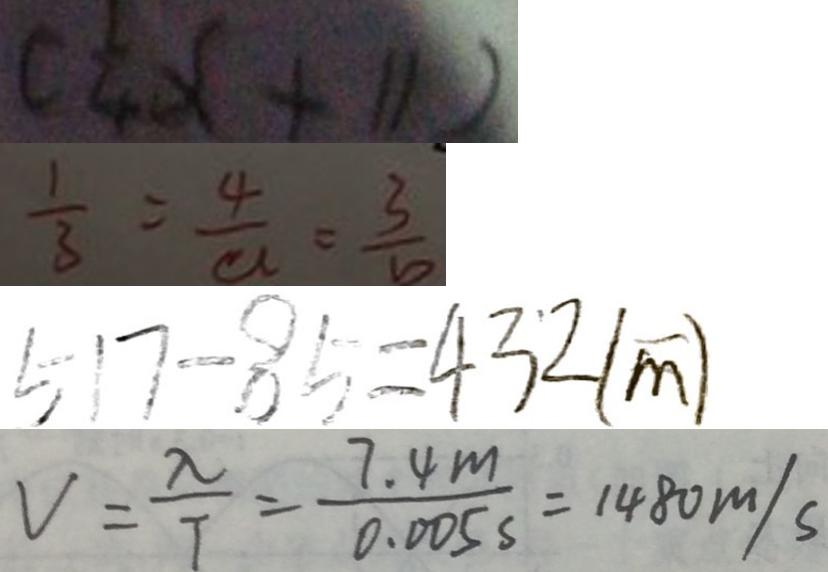Convert formula to latex. <formula><loc_0><loc_0><loc_500><loc_500>( \frac { 1 } { 4 } x + 1 1 ) 
 \frac { 1 } { 3 } = \frac { 4 } { a } = \frac { 3 } { b } 
 5 1 7 - 8 5 = 4 3 2 ( m ) 
 V = \frac { \lambda } { T } = \frac { 7 . 4 m } { 0 . 0 0 5 s } = 1 4 8 0 m / s</formula> 